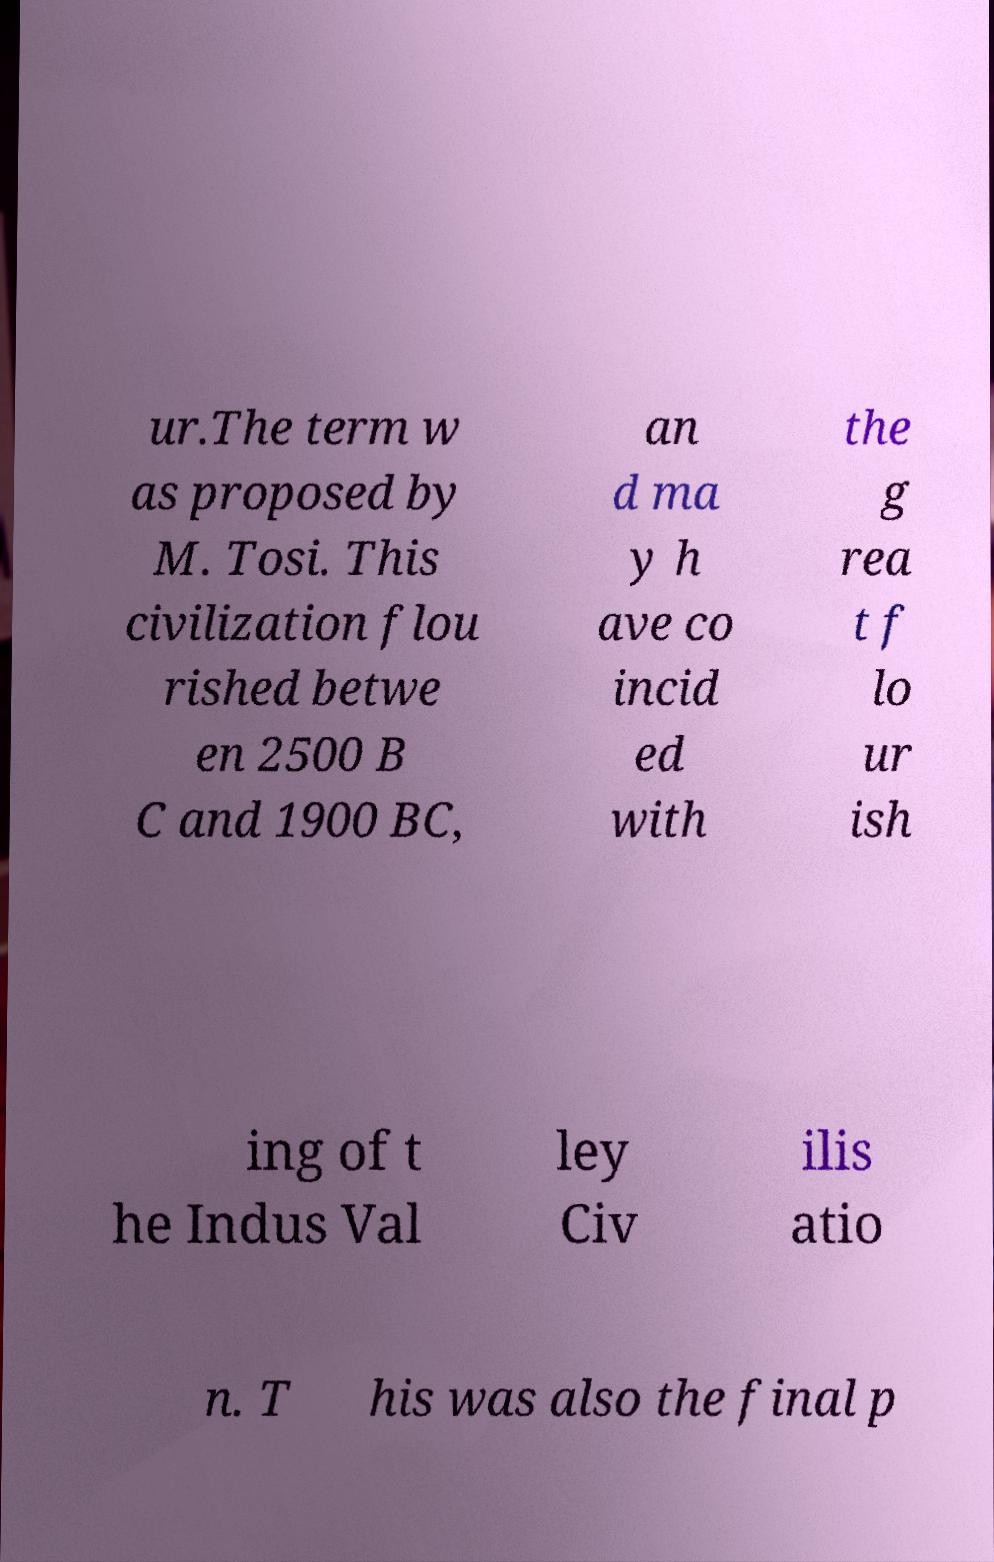Could you assist in decoding the text presented in this image and type it out clearly? ur.The term w as proposed by M. Tosi. This civilization flou rished betwe en 2500 B C and 1900 BC, an d ma y h ave co incid ed with the g rea t f lo ur ish ing of t he Indus Val ley Civ ilis atio n. T his was also the final p 